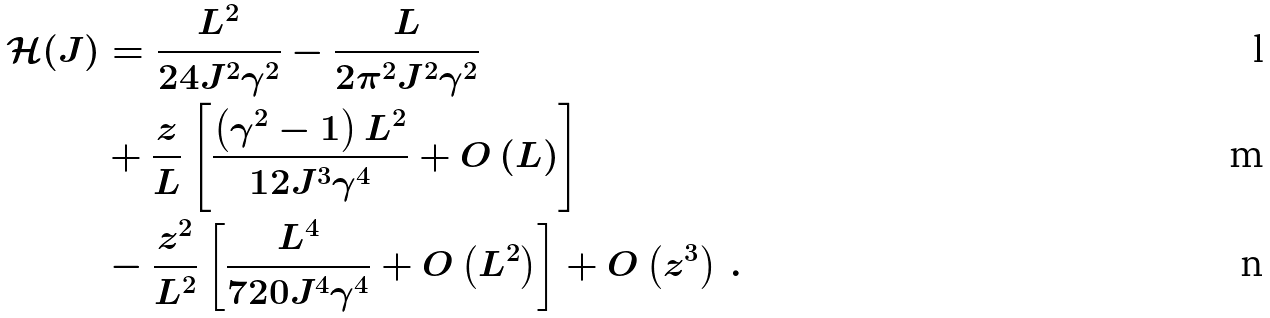<formula> <loc_0><loc_0><loc_500><loc_500>\mathcal { H } ( J ) & = \frac { L ^ { 2 } } { 2 4 J ^ { 2 } \gamma ^ { 2 } } - \frac { L } { 2 \pi ^ { 2 } J ^ { 2 } \gamma ^ { 2 } } \\ & + \frac { z } { L } \left [ \frac { \left ( \gamma ^ { 2 } - 1 \right ) L ^ { 2 } } { 1 2 J ^ { 3 } \gamma ^ { 4 } } + O \left ( L \right ) \right ] \\ & - \frac { z ^ { 2 } } { L ^ { 2 } } \left [ \frac { L ^ { 4 } } { 7 2 0 J ^ { 4 } \gamma ^ { 4 } } + O \left ( L ^ { 2 } \right ) \right ] + O \left ( z ^ { 3 } \right ) \, .</formula> 